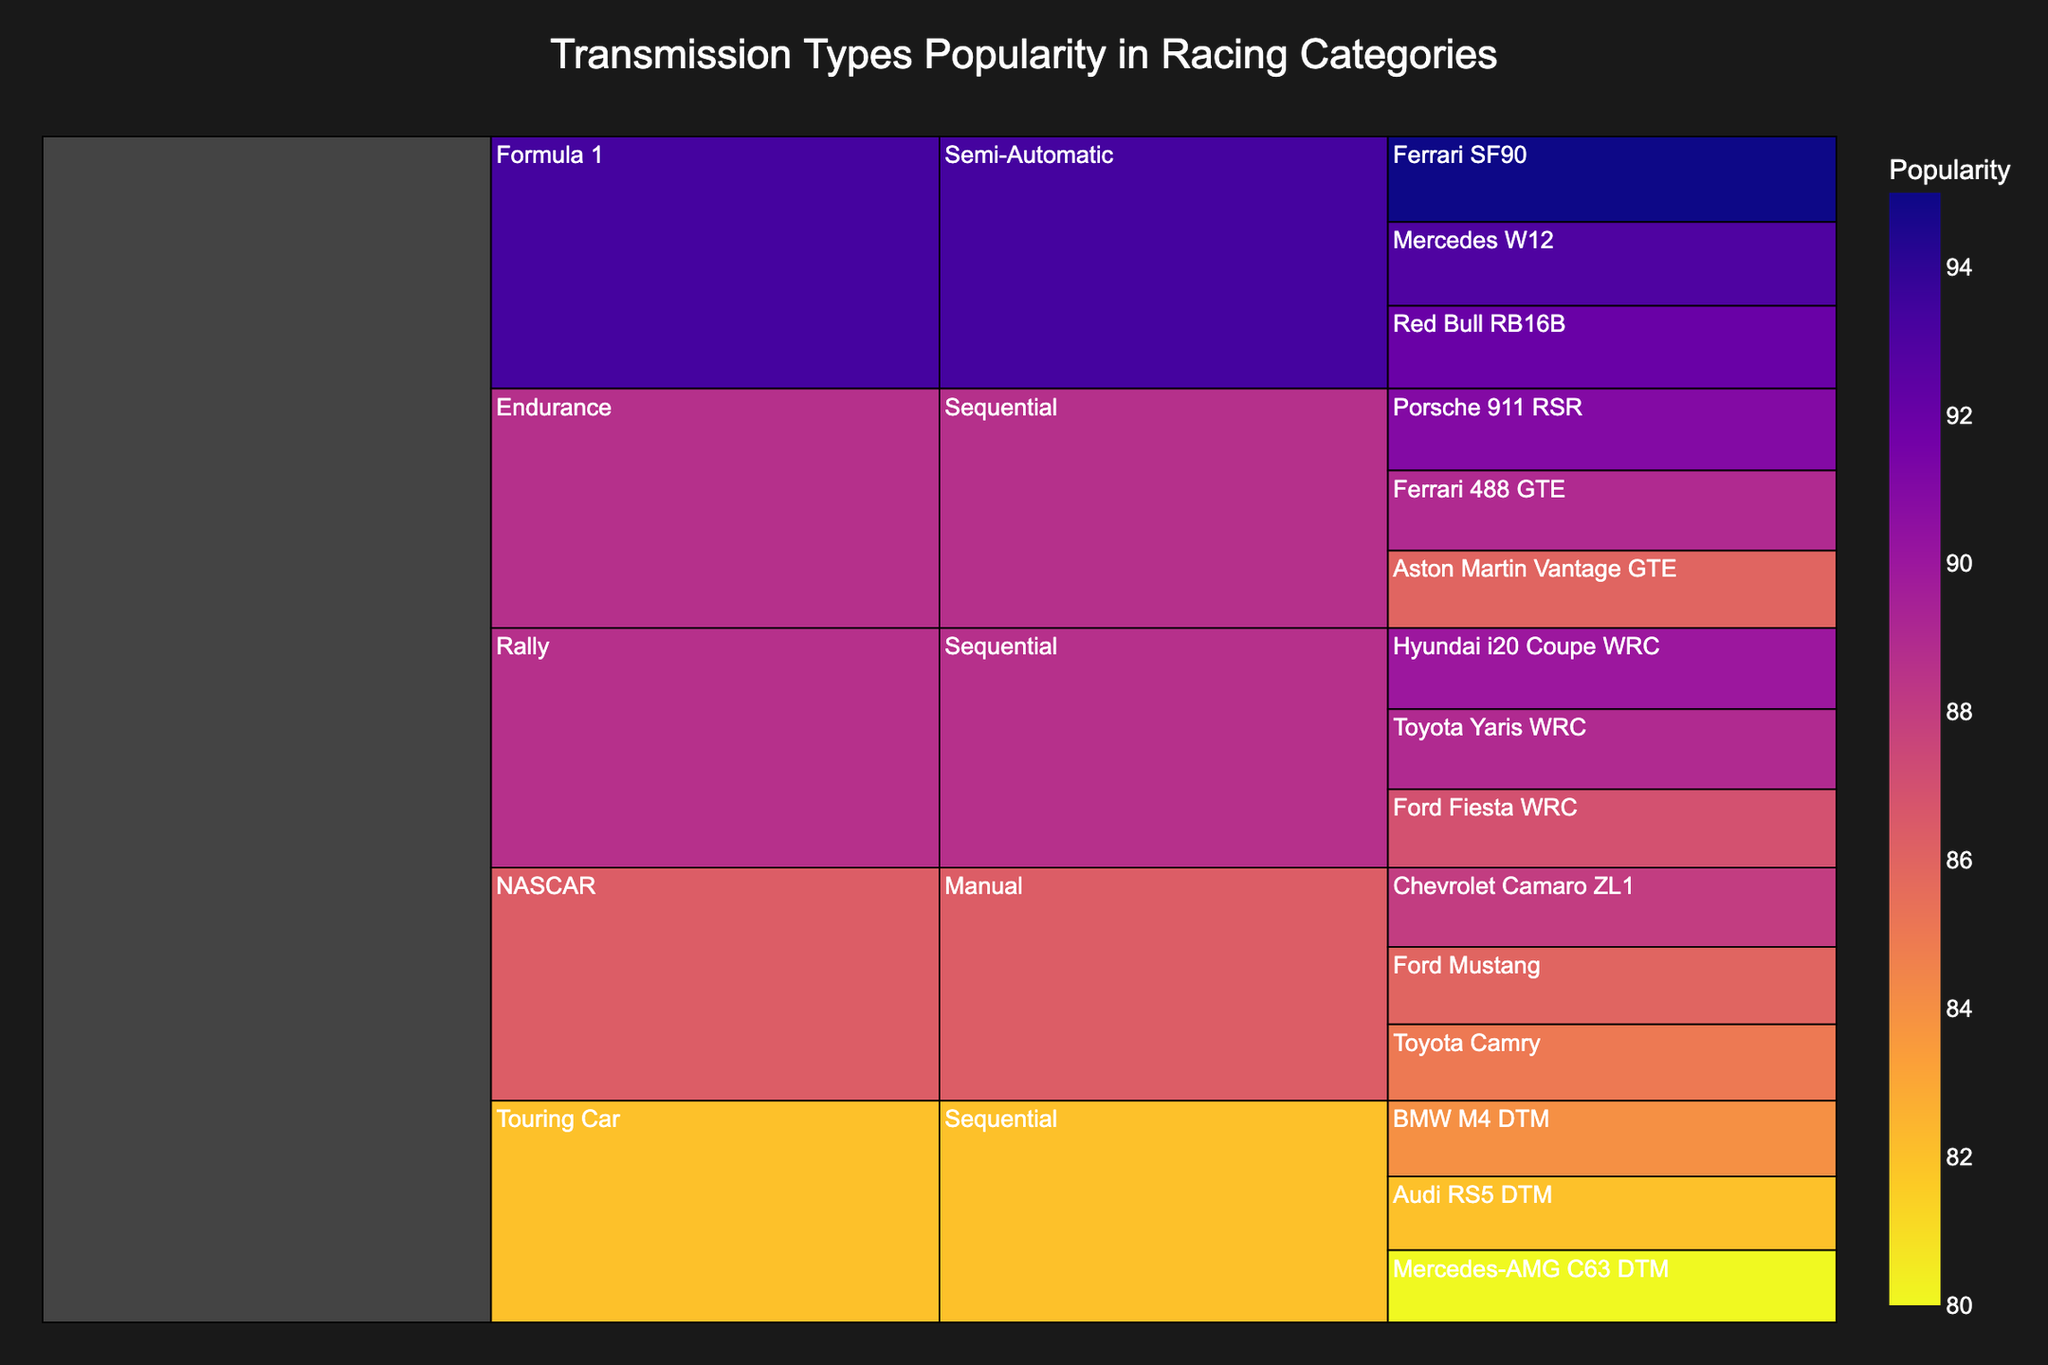Which category has the highest overall popularity based on transmission types? To find this, sum the popularity of all models within each category. Formula 1: 95 + 93 + 92 = 280, NASCAR: 88 + 86 + 85 = 259, Rally: 90 + 89 + 87 = 266, Endurance: 91 + 89 + 86 = 266, Touring Car: 84 + 82 + 80 = 246. Formula 1 has the highest overall popularity.
Answer: Formula 1 Which model in Formula 1 has the highest popularity? Look at the values for each model within the Formula 1 category. Ferrari SF90: 95, Mercedes W12: 93, Red Bull RB16B: 92. Ferrari SF90 has the highest popularity.
Answer: Ferrari SF90 How does the popularity of the top model in Endurance compare to the top model in Rally? Find the top models for Endurance and Rally. Endurance: Porsche 911 RSR (91), Rally: Hyundai i20 Coupe WRC (90). Compare the two values, 91 is greater than 90.
Answer: Porsche 911 RSR is more popular than Hyundai i20 Coupe WRC What is the total popularity of all models in the Sequential transmission type? Sum the popularity of all models using Sequential transmission. Hyundai i20 Coupe WRC: 90, Toyota Yaris WRC: 89, Ford Fiesta WRC: 87, Porsche 911 RSR: 91, Ferrari 488 GTE: 89, Aston Martin Vantage GTE: 86, BMW M4 DTM: 84, Audi RS5 DTM: 82, Mercedes-AMG C63 DTM: 80. Total = 90 + 89 + 87 + 91 + 89 + 86 + 84 + 82 + 80 = 678.
Answer: 678 Which category has the least number of models represented? Count the number of models under each category. Formula 1: 3, NASCAR: 3, Rally: 3, Endurance: 3, Touring Car: 3. All categories have equal number of models.
Answer: All categories have 3 models What is the average popularity of models in the NASCAR category? Calculate the average popularity for NASCAR models. Sum the popularity values and divide by the number of models. Total popularity of NASCAR: 88 + 86 + 85 = 259. Number of models: 3. Average = 259 / 3 ≈ 86.33.
Answer: 86.33 How does the popularity of the Toyota Camry in NASCAR compare to the BMW M4 DTM in Touring Car? Compare the popularity values for the Toyota Camry and BMW M4 DTM. Toyota Camry: 85, BMW M4 DTM: 84. Toyota Camry has higher popularity.
Answer: Toyota Camry is more popular What is the most popular transmission type in the Rally category? Look at the Rally category's transmission types. All models (Hyundai i20 Coupe WRC, Toyota Yaris WRC, Ford Fiesta WRC) use Sequential transmission type.
Answer: Sequential How does the combined popularity of Sequential transmissions in Touring Car compare to Manual transmissions in NASCAR? Sum the popularity of models using Sequential transmissions in Touring Car and Manual transmissions in NASCAR. Touring Car: 84 + 82 + 80 = 246. NASCAR: 88 + 86 + 85 = 259. Touring Car has less popularity.
Answer: NASCAR has higher popularity Which model in the Sequential transmission category has the lowest popularity? Check each model's popularity within the Sequential transmission. Mercedes-AMG C63 DTM: 80 has the lowest popularity.
Answer: Mercedes-AMG C63 DTM 